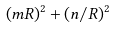<formula> <loc_0><loc_0><loc_500><loc_500>( m R ) ^ { 2 } + ( n / R ) ^ { 2 }</formula> 